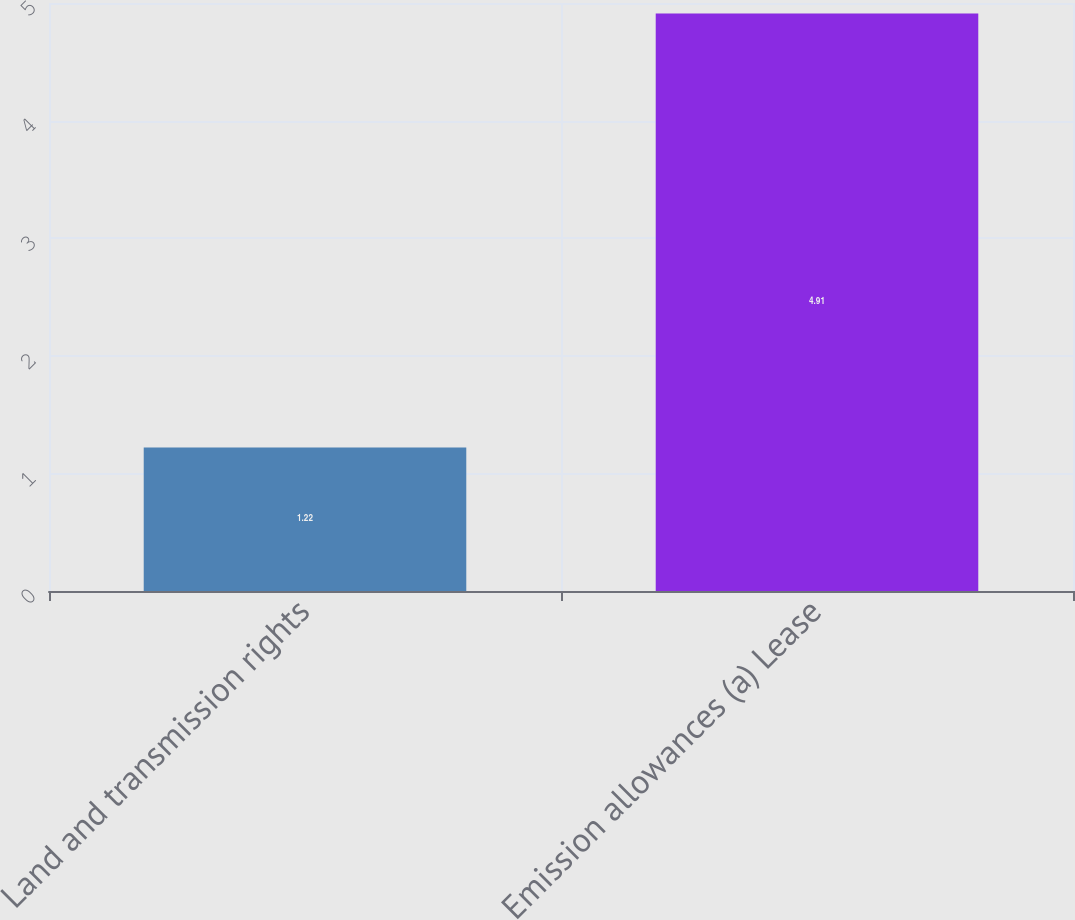Convert chart. <chart><loc_0><loc_0><loc_500><loc_500><bar_chart><fcel>Land and transmission rights<fcel>Emission allowances (a) Lease<nl><fcel>1.22<fcel>4.91<nl></chart> 